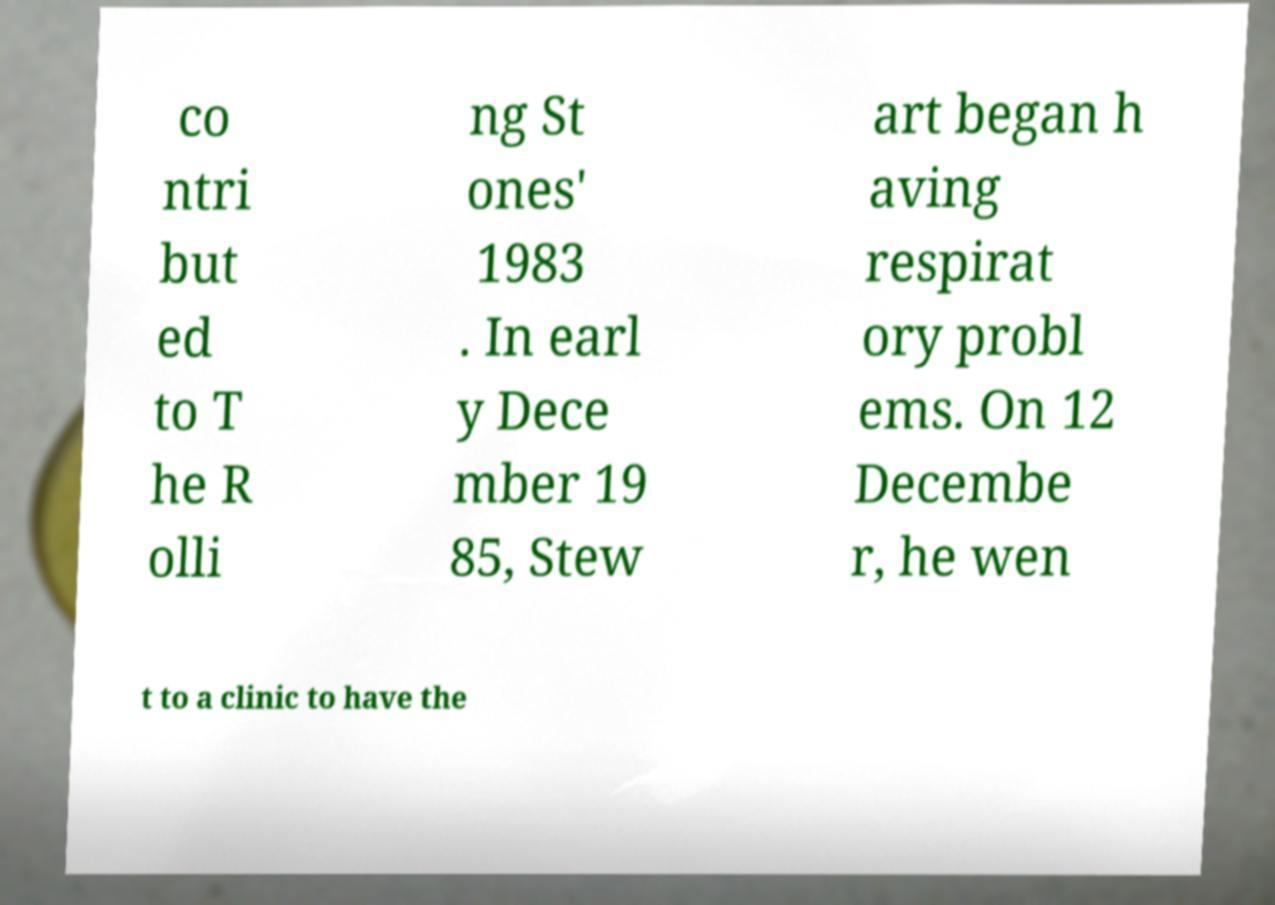I need the written content from this picture converted into text. Can you do that? co ntri but ed to T he R olli ng St ones' 1983 . In earl y Dece mber 19 85, Stew art began h aving respirat ory probl ems. On 12 Decembe r, he wen t to a clinic to have the 